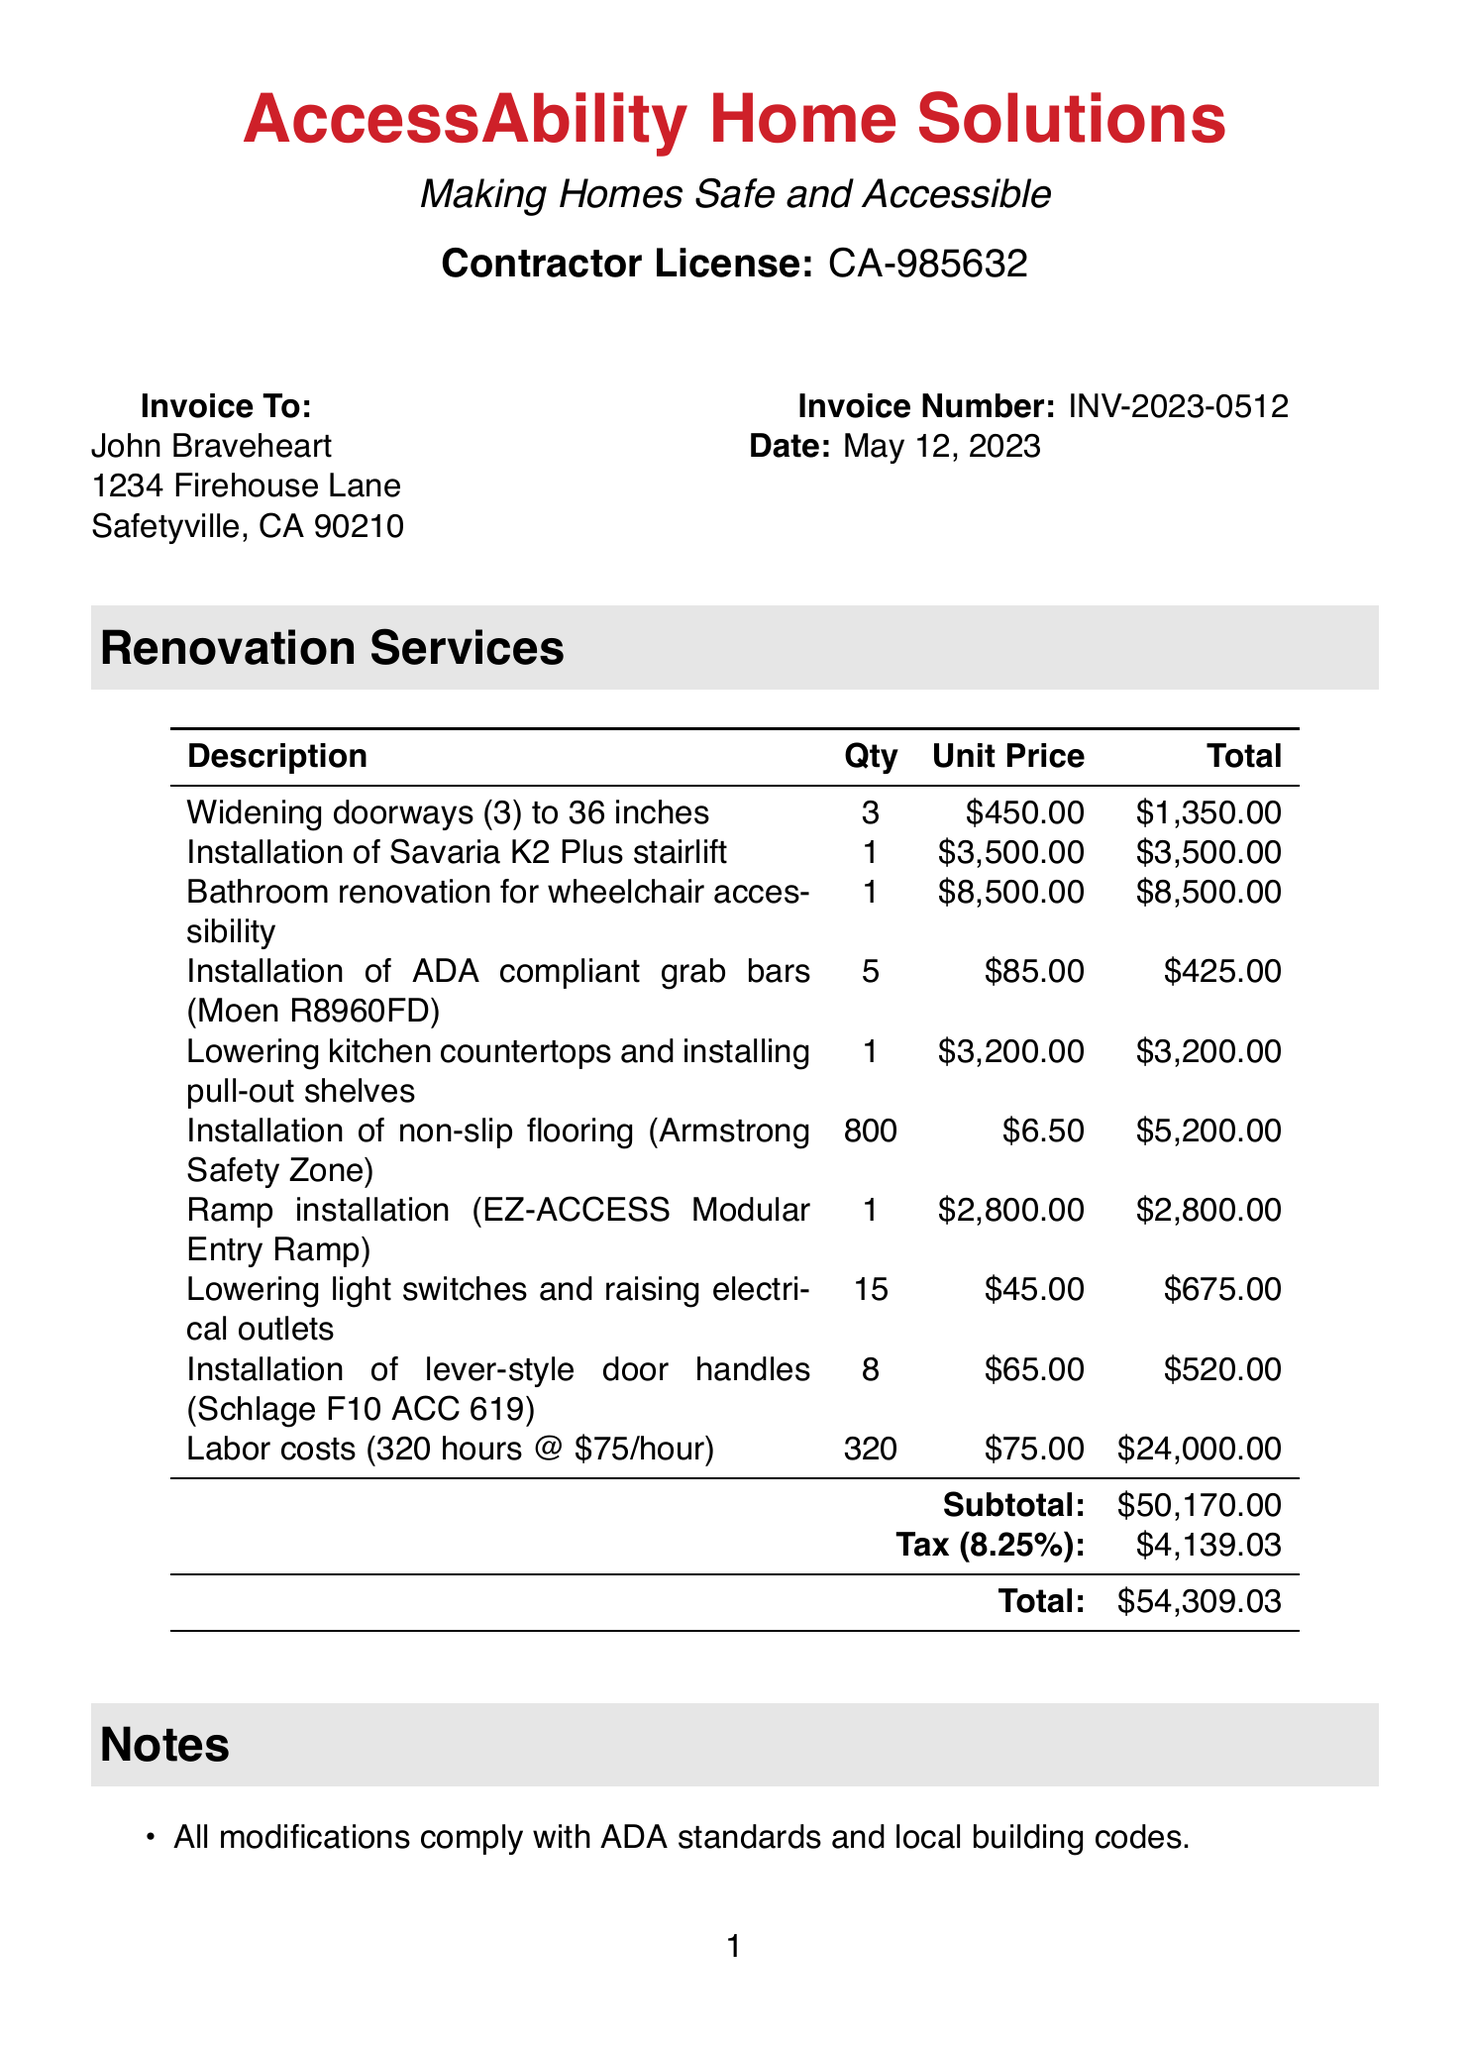What is the invoice number? The invoice number is a unique identifier for the document, specified clearly at the top.
Answer: INV-2023-0512 Who is the client? The client's name is listed in the "Invoice To" section of the document.
Answer: John Braveheart What is the total amount due? The total amount is calculated at the end of the invoice, which includes subtotal and tax.
Answer: 54309.03 What is the contractor's license number? The contractor's license number is provided under the contractor information section.
Answer: CA-985632 How many hours of labor were charged? The labor costs entry includes the total hours worked, which is specified in the description.
Answer: 320 What is the tax rate applied? The tax rate is explicitly mentioned in the invoice and affects the total amount.
Answer: 8.25% What modification was made for the kitchen? The kitchen modification is described under the items section with details of what was changed.
Answer: Lowering kitchen countertops and installing pull-out shelves What discount was applied to labor costs? The invoice notes the type of discount applied to labor costs that honors the client's service.
Answer: 10% What feature was added for fire safety? The document notes certain features that enhance fire safety in the renovation.
Answer: Additional smoke detectors When is payment due? The due date for payment is specified in the notes section of the invoice.
Answer: Within 30 days 